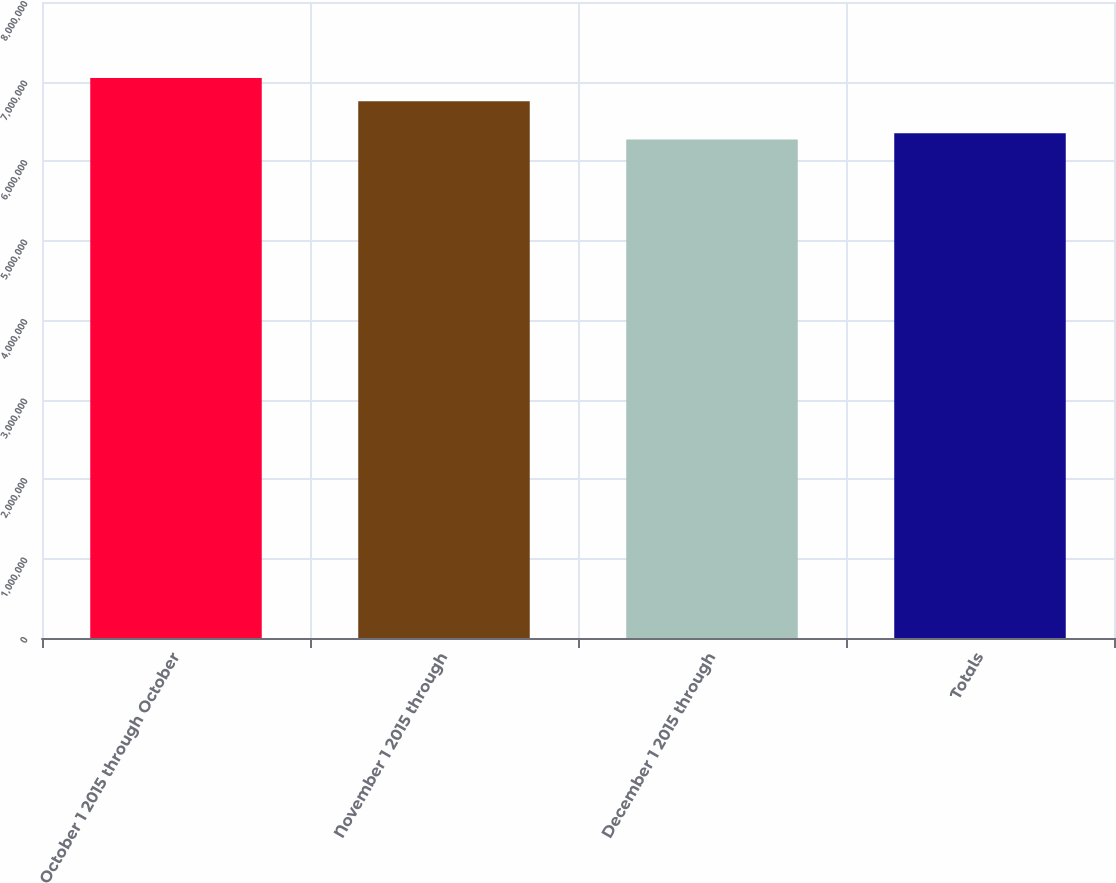Convert chart to OTSL. <chart><loc_0><loc_0><loc_500><loc_500><bar_chart><fcel>October 1 2015 through October<fcel>November 1 2015 through<fcel>December 1 2015 through<fcel>Totals<nl><fcel>7.04287e+06<fcel>6.75284e+06<fcel>6.272e+06<fcel>6.34908e+06<nl></chart> 